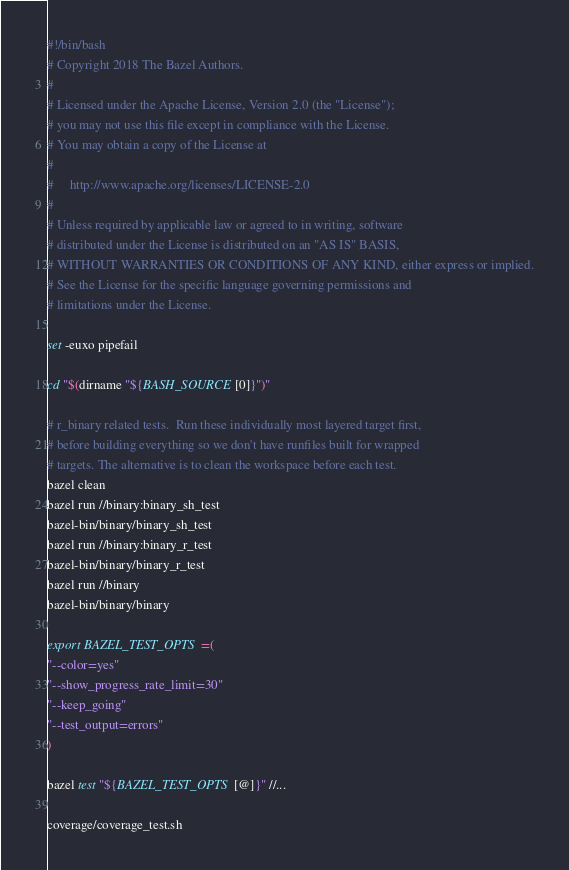<code> <loc_0><loc_0><loc_500><loc_500><_Bash_>#!/bin/bash
# Copyright 2018 The Bazel Authors.
#
# Licensed under the Apache License, Version 2.0 (the "License");
# you may not use this file except in compliance with the License.
# You may obtain a copy of the License at
#
#     http://www.apache.org/licenses/LICENSE-2.0
#
# Unless required by applicable law or agreed to in writing, software
# distributed under the License is distributed on an "AS IS" BASIS,
# WITHOUT WARRANTIES OR CONDITIONS OF ANY KIND, either express or implied.
# See the License for the specific language governing permissions and
# limitations under the License.

set -euxo pipefail

cd "$(dirname "${BASH_SOURCE[0]}")"

# r_binary related tests.  Run these individually most layered target first,
# before building everything so we don't have runfiles built for wrapped
# targets. The alternative is to clean the workspace before each test.
bazel clean
bazel run //binary:binary_sh_test
bazel-bin/binary/binary_sh_test
bazel run //binary:binary_r_test
bazel-bin/binary/binary_r_test
bazel run //binary
bazel-bin/binary/binary

export BAZEL_TEST_OPTS=(
"--color=yes"
"--show_progress_rate_limit=30"
"--keep_going"
"--test_output=errors"
)

bazel test "${BAZEL_TEST_OPTS[@]}" //...

coverage/coverage_test.sh
</code> 